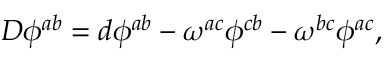Convert formula to latex. <formula><loc_0><loc_0><loc_500><loc_500>D \phi ^ { a b } = d \phi ^ { a b } - \omega ^ { a c } \phi ^ { c b } - \omega ^ { b c } \phi ^ { a c } ,</formula> 